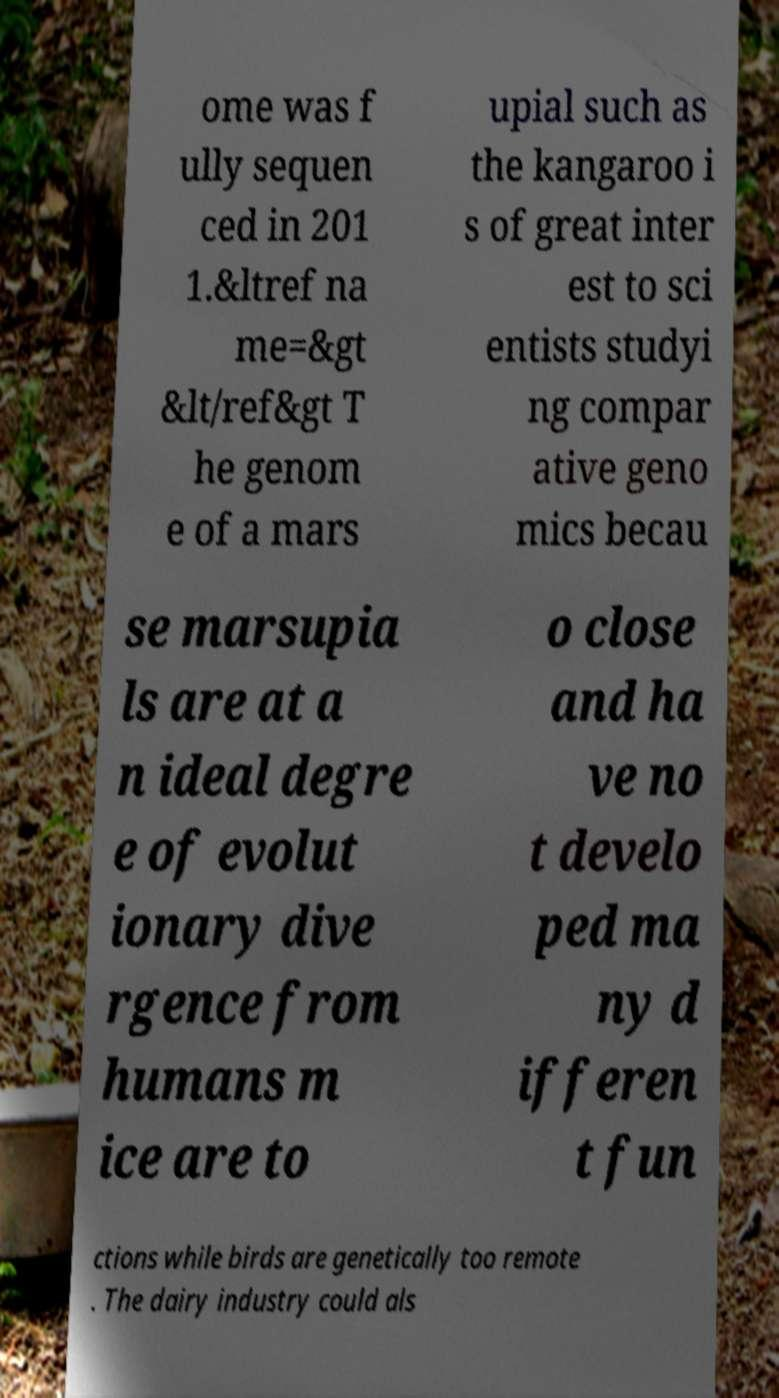What messages or text are displayed in this image? I need them in a readable, typed format. ome was f ully sequen ced in 201 1.&ltref na me=&gt &lt/ref&gt T he genom e of a mars upial such as the kangaroo i s of great inter est to sci entists studyi ng compar ative geno mics becau se marsupia ls are at a n ideal degre e of evolut ionary dive rgence from humans m ice are to o close and ha ve no t develo ped ma ny d ifferen t fun ctions while birds are genetically too remote . The dairy industry could als 